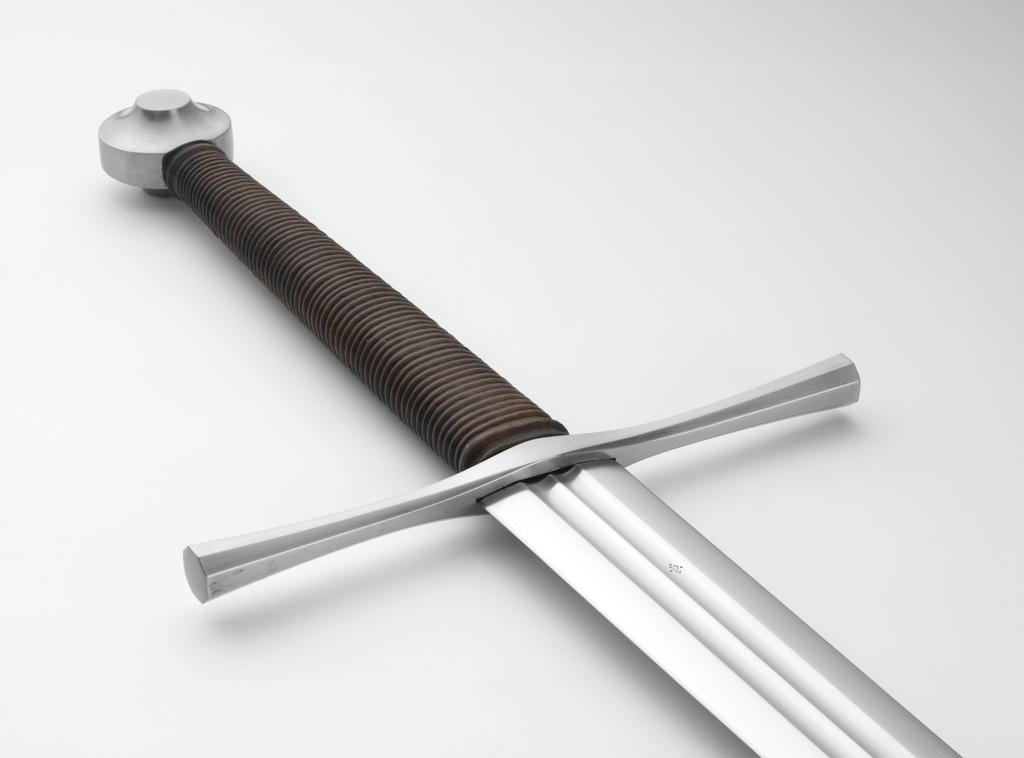What object can be seen in the image? There is a sword in the image. How is the sword positioned in the image? The sword is placed on a surface. What color is the background of the image? The background of the image is white in color. Is there an umbrella being used to distribute the sword in the image? There is no umbrella present in the image, and the sword is simply placed on a surface. 